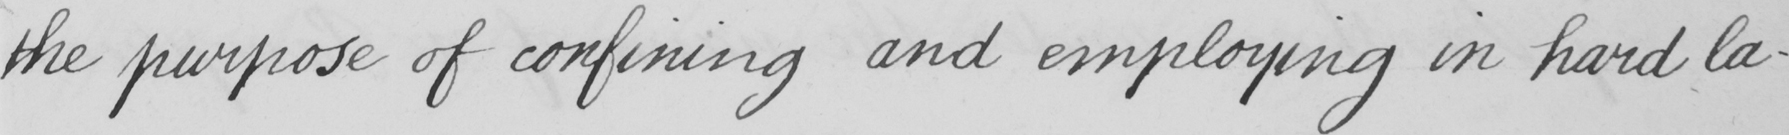What text is written in this handwritten line? the purpose of confining and employing in hard la- 